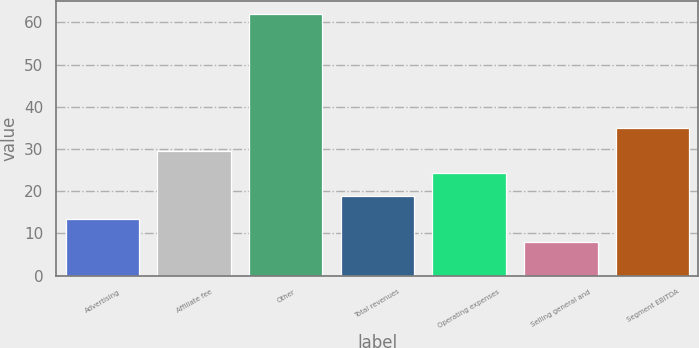Convert chart. <chart><loc_0><loc_0><loc_500><loc_500><bar_chart><fcel>Advertising<fcel>Affiliate fee<fcel>Other<fcel>Total revenues<fcel>Operating expenses<fcel>Selling general and<fcel>Segment EBITDA<nl><fcel>13.4<fcel>29.6<fcel>62<fcel>18.8<fcel>24.2<fcel>8<fcel>35<nl></chart> 